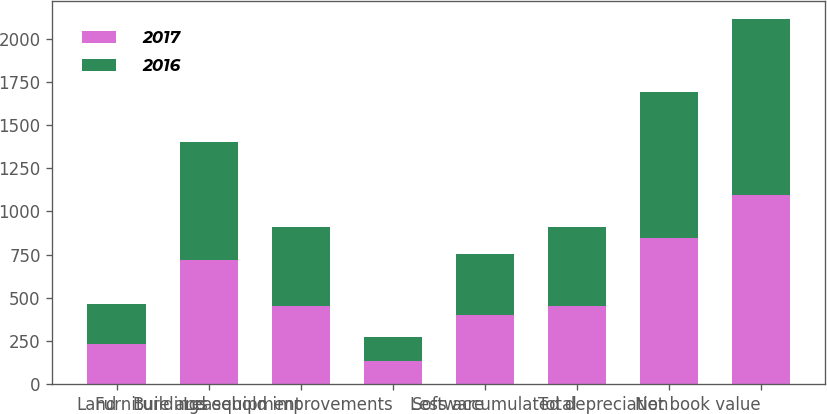<chart> <loc_0><loc_0><loc_500><loc_500><stacked_bar_chart><ecel><fcel>Land<fcel>Buildings<fcel>Furniture and equipment<fcel>Leasehold improvements<fcel>Software<fcel>Total<fcel>Less accumulated depreciation<fcel>Net book value<nl><fcel>2017<fcel>234<fcel>720<fcel>451<fcel>135<fcel>401<fcel>454.5<fcel>847<fcel>1094<nl><fcel>2016<fcel>229<fcel>683<fcel>458<fcel>140<fcel>355<fcel>454.5<fcel>845<fcel>1020<nl></chart> 